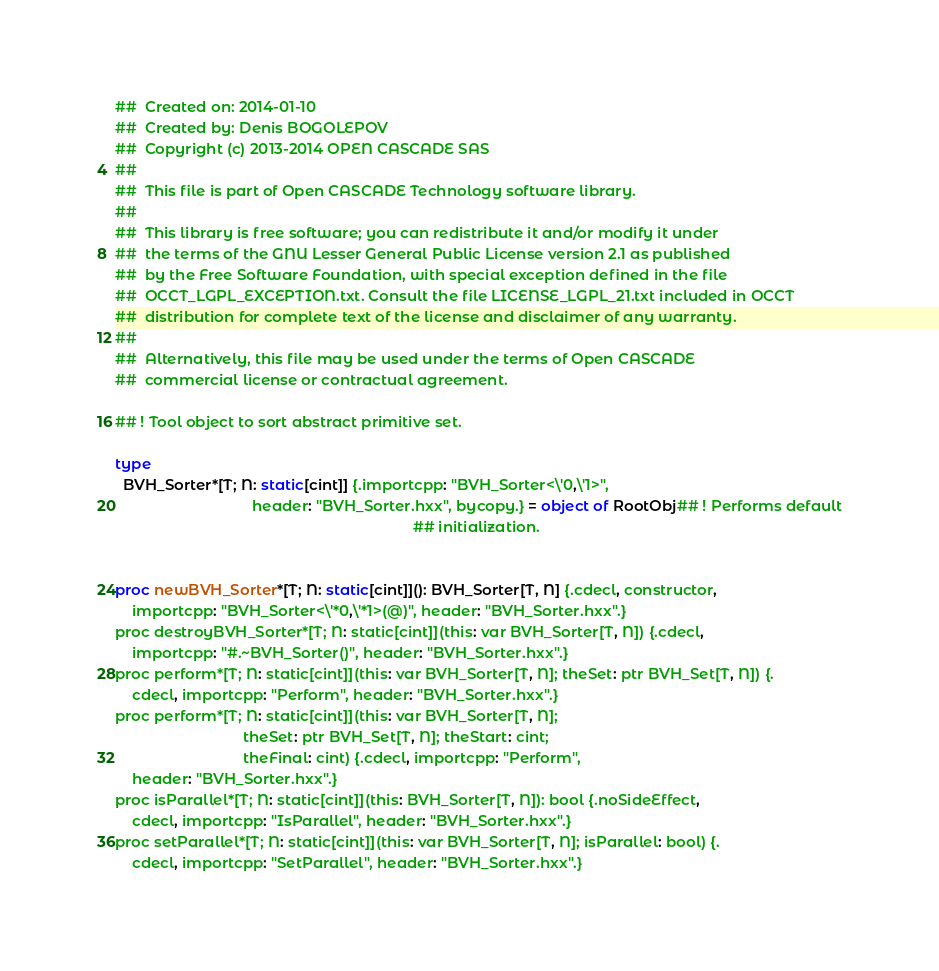<code> <loc_0><loc_0><loc_500><loc_500><_Nim_>##  Created on: 2014-01-10
##  Created by: Denis BOGOLEPOV
##  Copyright (c) 2013-2014 OPEN CASCADE SAS
##
##  This file is part of Open CASCADE Technology software library.
##
##  This library is free software; you can redistribute it and/or modify it under
##  the terms of the GNU Lesser General Public License version 2.1 as published
##  by the Free Software Foundation, with special exception defined in the file
##  OCCT_LGPL_EXCEPTION.txt. Consult the file LICENSE_LGPL_21.txt included in OCCT
##  distribution for complete text of the license and disclaimer of any warranty.
##
##  Alternatively, this file may be used under the terms of Open CASCADE
##  commercial license or contractual agreement.

## ! Tool object to sort abstract primitive set.

type
  BVH_Sorter*[T; N: static[cint]] {.importcpp: "BVH_Sorter<\'0,\'1>",
                                 header: "BVH_Sorter.hxx", bycopy.} = object of RootObj## ! Performs default
                                                                        ## initialization.


proc newBVH_Sorter*[T; N: static[cint]](): BVH_Sorter[T, N] {.cdecl, constructor,
    importcpp: "BVH_Sorter<\'*0,\'*1>(@)", header: "BVH_Sorter.hxx".}
proc destroyBVH_Sorter*[T; N: static[cint]](this: var BVH_Sorter[T, N]) {.cdecl,
    importcpp: "#.~BVH_Sorter()", header: "BVH_Sorter.hxx".}
proc perform*[T; N: static[cint]](this: var BVH_Sorter[T, N]; theSet: ptr BVH_Set[T, N]) {.
    cdecl, importcpp: "Perform", header: "BVH_Sorter.hxx".}
proc perform*[T; N: static[cint]](this: var BVH_Sorter[T, N];
                               theSet: ptr BVH_Set[T, N]; theStart: cint;
                               theFinal: cint) {.cdecl, importcpp: "Perform",
    header: "BVH_Sorter.hxx".}
proc isParallel*[T; N: static[cint]](this: BVH_Sorter[T, N]): bool {.noSideEffect,
    cdecl, importcpp: "IsParallel", header: "BVH_Sorter.hxx".}
proc setParallel*[T; N: static[cint]](this: var BVH_Sorter[T, N]; isParallel: bool) {.
    cdecl, importcpp: "SetParallel", header: "BVH_Sorter.hxx".}</code> 